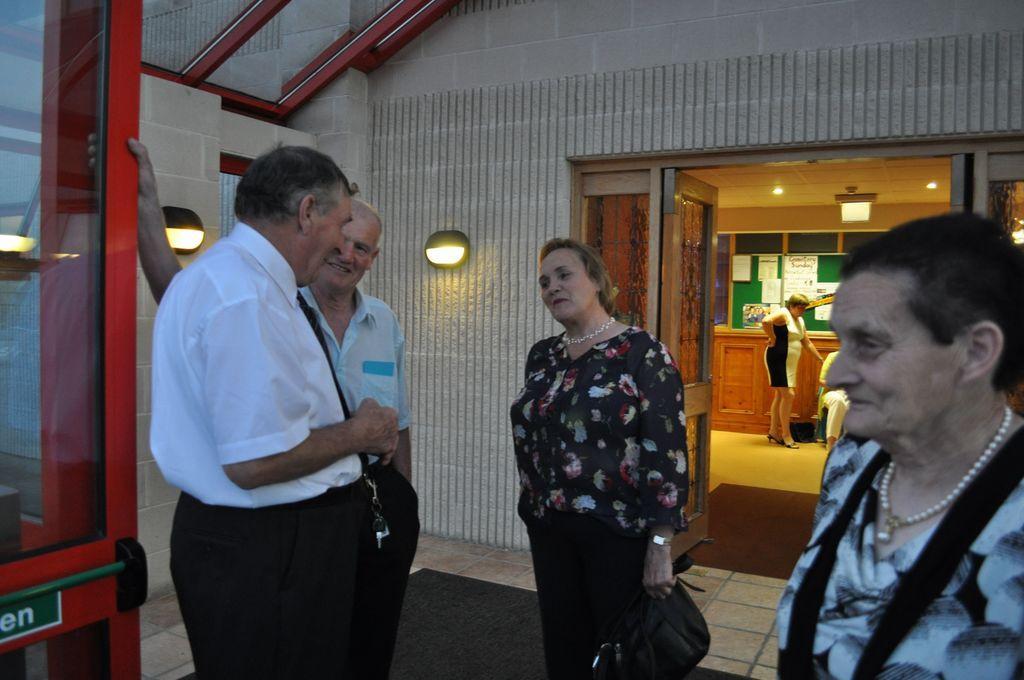How would you summarize this image in a sentence or two? In the image in the center we can see four people were standing and they were holding some objects. And they were smiling,which we can see on their faces. In the background there is a wall,roof,board,table,lights,notes,carpets and few people were standing. 